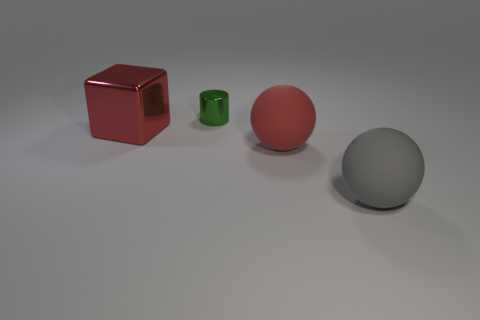Add 1 tiny shiny objects. How many objects exist? 5 Subtract all gray balls. How many balls are left? 1 Subtract 1 spheres. How many spheres are left? 1 Subtract all yellow cylinders. How many red spheres are left? 1 Subtract all big brown rubber balls. Subtract all large gray matte spheres. How many objects are left? 3 Add 4 big red balls. How many big red balls are left? 5 Add 3 tiny things. How many tiny things exist? 4 Subtract 0 gray cylinders. How many objects are left? 4 Subtract all cubes. How many objects are left? 3 Subtract all cyan cylinders. Subtract all blue spheres. How many cylinders are left? 1 